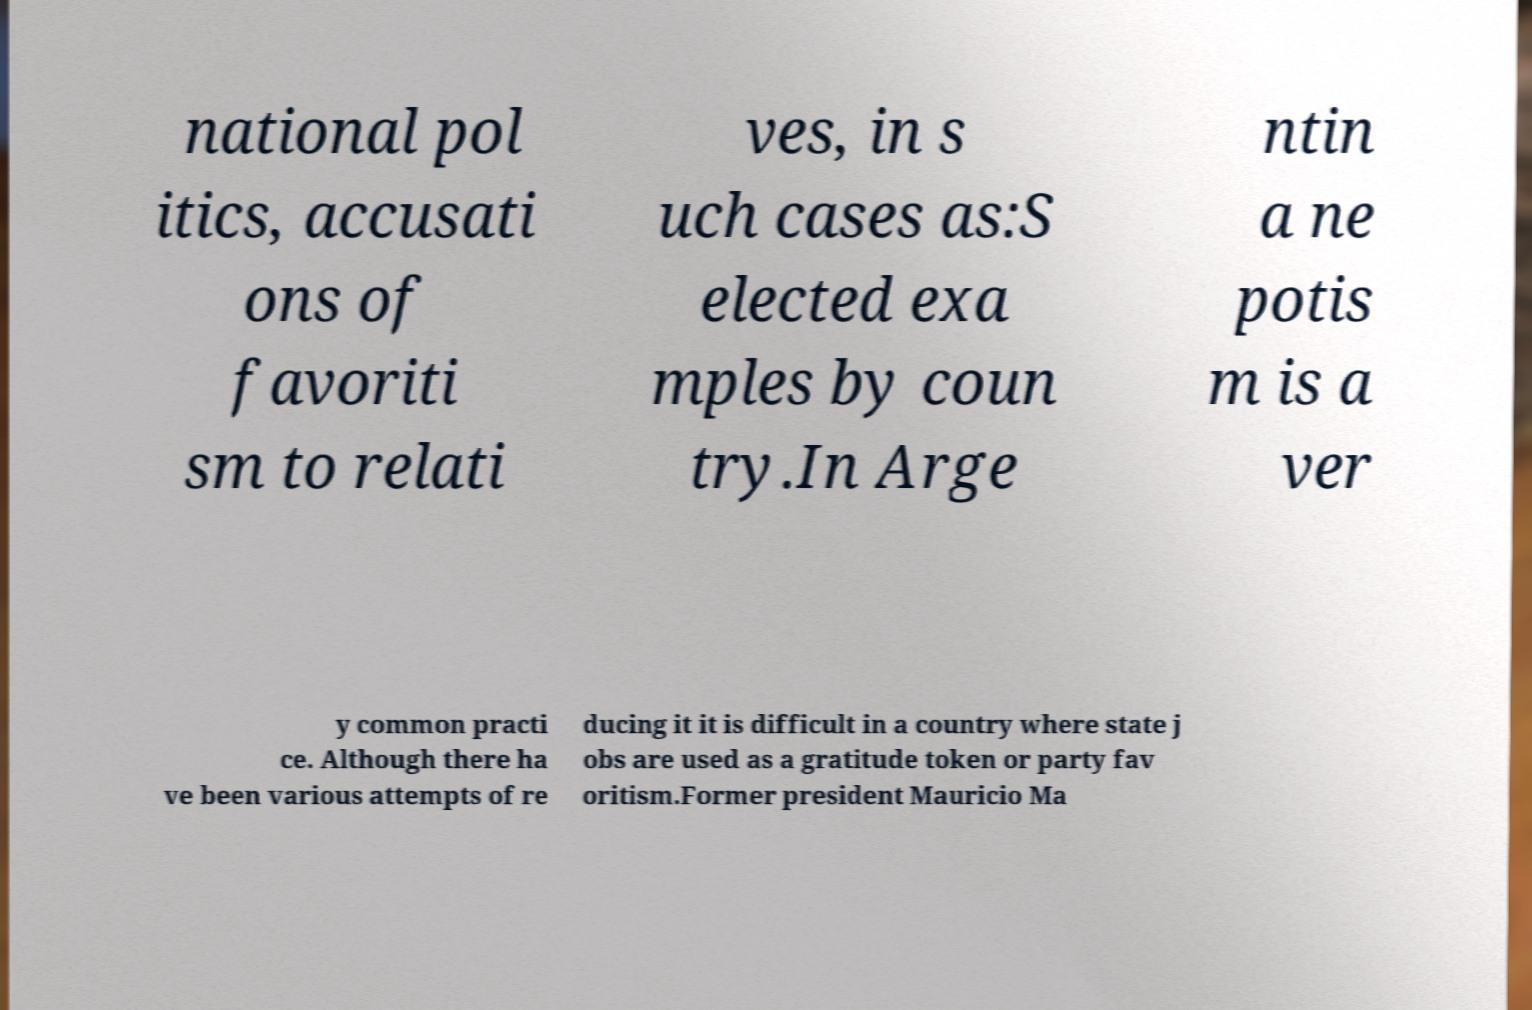Can you read and provide the text displayed in the image?This photo seems to have some interesting text. Can you extract and type it out for me? national pol itics, accusati ons of favoriti sm to relati ves, in s uch cases as:S elected exa mples by coun try.In Arge ntin a ne potis m is a ver y common practi ce. Although there ha ve been various attempts of re ducing it it is difficult in a country where state j obs are used as a gratitude token or party fav oritism.Former president Mauricio Ma 